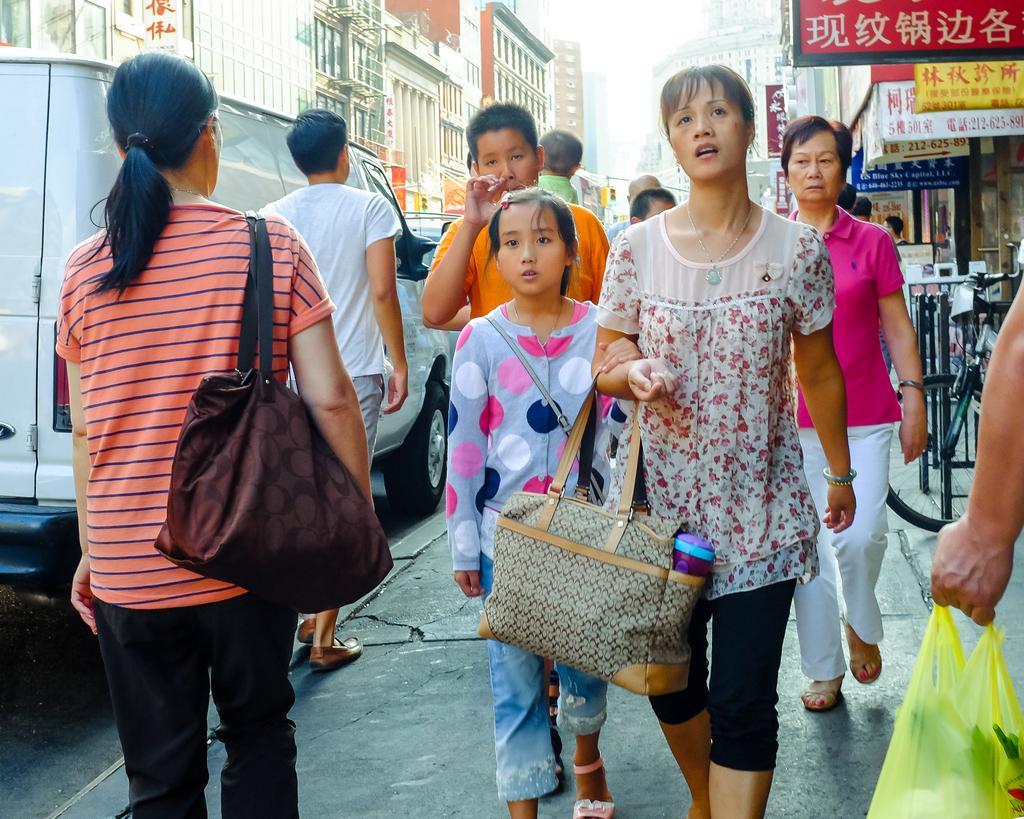Describe this image in one or two sentences. In this picture these persons are walking. On this background we can see buildings. There is a vehicle on the road. This person hold a bag. This person wear a bag. We can see boards. 